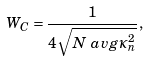<formula> <loc_0><loc_0><loc_500><loc_500>W _ { C } & = \frac { 1 } { 4 \sqrt { N \ a v g { \kappa _ { n } ^ { 2 } } } } ,</formula> 